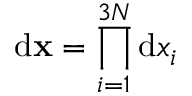Convert formula to latex. <formula><loc_0><loc_0><loc_500><loc_500>{ d } { x } = \prod _ { i = 1 } ^ { 3 N } { d } x _ { i }</formula> 